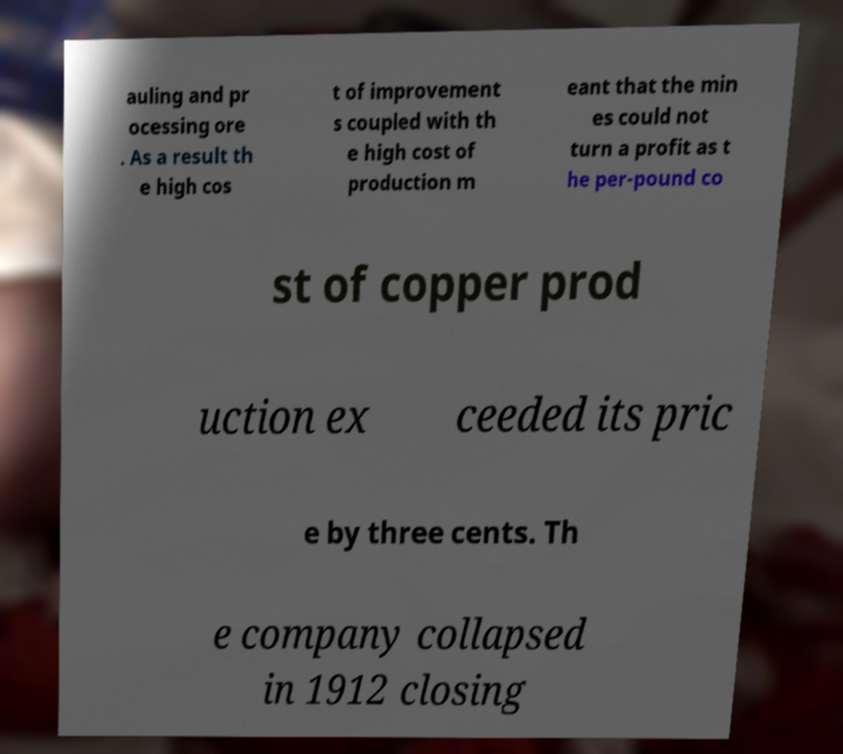Please read and relay the text visible in this image. What does it say? auling and pr ocessing ore . As a result th e high cos t of improvement s coupled with th e high cost of production m eant that the min es could not turn a profit as t he per-pound co st of copper prod uction ex ceeded its pric e by three cents. Th e company collapsed in 1912 closing 